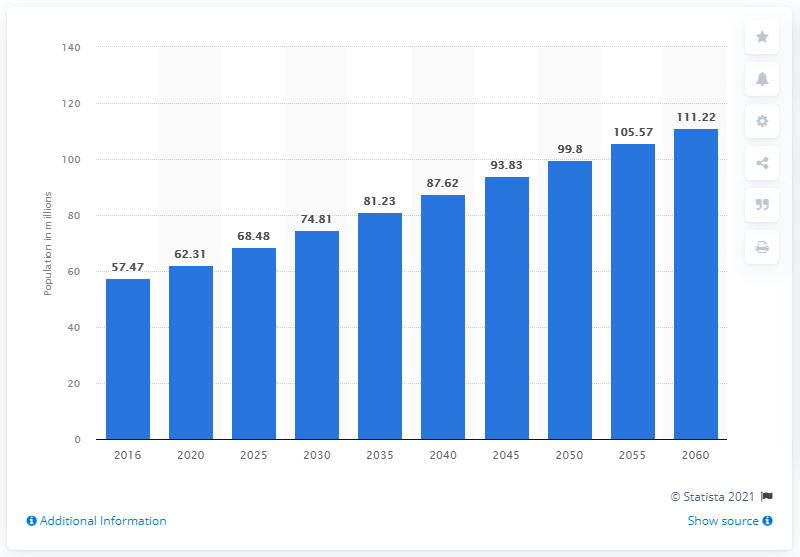Highlight a few significant elements in this photo. The graph revealed that the Hispanic population in the US peaked in 2016. The number of people of Hispanic descent in the United States is projected to be 111.22 million in the year 2060. 